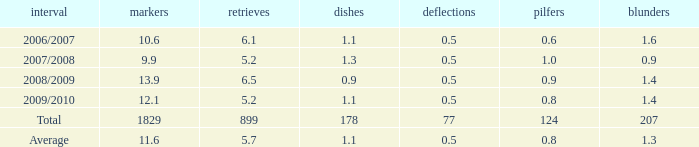How many blocks are there when the rebounds are fewer than 5.2? 0.0. Would you mind parsing the complete table? {'header': ['interval', 'markers', 'retrieves', 'dishes', 'deflections', 'pilfers', 'blunders'], 'rows': [['2006/2007', '10.6', '6.1', '1.1', '0.5', '0.6', '1.6'], ['2007/2008', '9.9', '5.2', '1.3', '0.5', '1.0', '0.9'], ['2008/2009', '13.9', '6.5', '0.9', '0.5', '0.9', '1.4'], ['2009/2010', '12.1', '5.2', '1.1', '0.5', '0.8', '1.4'], ['Total', '1829', '899', '178', '77', '124', '207'], ['Average', '11.6', '5.7', '1.1', '0.5', '0.8', '1.3']]} 